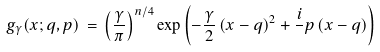<formula> <loc_0><loc_0><loc_500><loc_500>g _ { \gamma } ( { x } ; { q } , { p } ) \, = \, \left ( \frac { \gamma } { \pi } \right ) ^ { n / 4 } \exp \left ( - \frac { \gamma } { 2 } \left ( { x } - { q } \right ) ^ { 2 } + \frac { i } { } { p } \left ( { x } - { q } \right ) \right )</formula> 